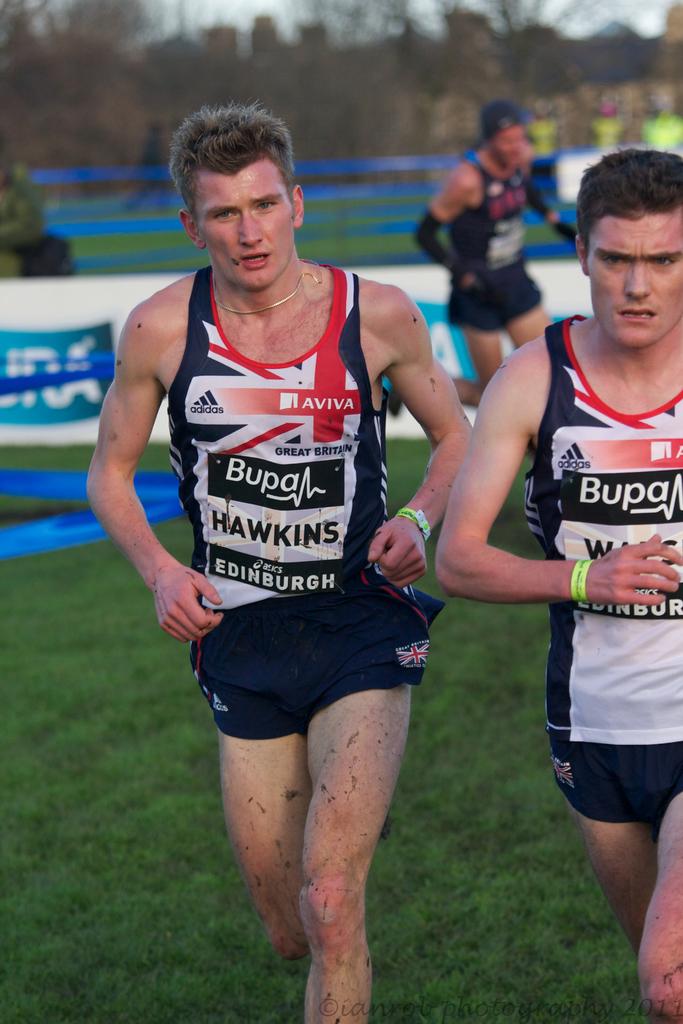What is the name of the player with lighter colored hair?
Make the answer very short. Hawkins. 